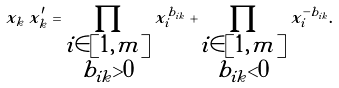Convert formula to latex. <formula><loc_0><loc_0><loc_500><loc_500>x _ { k } \, x ^ { \prime } _ { k } = \prod _ { \substack { i \in [ 1 , m ] \\ b _ { i k } > 0 } } x _ { i } ^ { b _ { i k } } + \prod _ { \substack { i \in [ 1 , m ] \\ b _ { i k } < 0 } } x _ { i } ^ { - b _ { i k } } .</formula> 